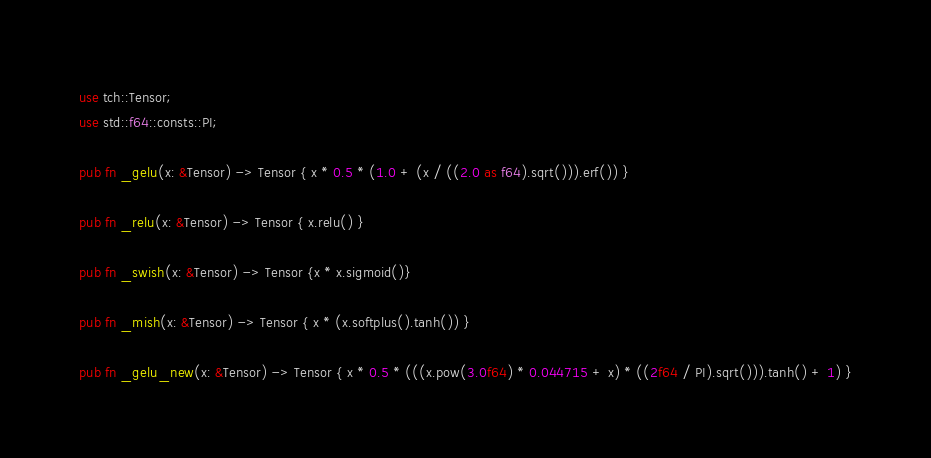<code> <loc_0><loc_0><loc_500><loc_500><_Rust_>use tch::Tensor;
use std::f64::consts::PI;

pub fn _gelu(x: &Tensor) -> Tensor { x * 0.5 * (1.0 + (x / ((2.0 as f64).sqrt())).erf()) }

pub fn _relu(x: &Tensor) -> Tensor { x.relu() }

pub fn _swish(x: &Tensor) -> Tensor {x * x.sigmoid()}

pub fn _mish(x: &Tensor) -> Tensor { x * (x.softplus().tanh()) }

pub fn _gelu_new(x: &Tensor) -> Tensor { x * 0.5 * (((x.pow(3.0f64) * 0.044715 + x) * ((2f64 / PI).sqrt())).tanh() + 1) }</code> 